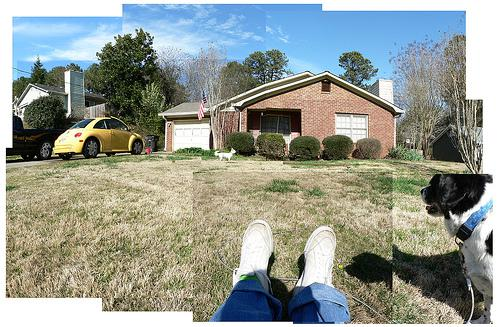Question: when was this taken?
Choices:
A. At night.
B. Day time.
C. At dawn.
D. At dusk.
Answer with the letter. Answer: B Question: how many shoes are visible?
Choices:
A. 2.
B. 7.
C. 8.
D. 6.
Answer with the letter. Answer: A 